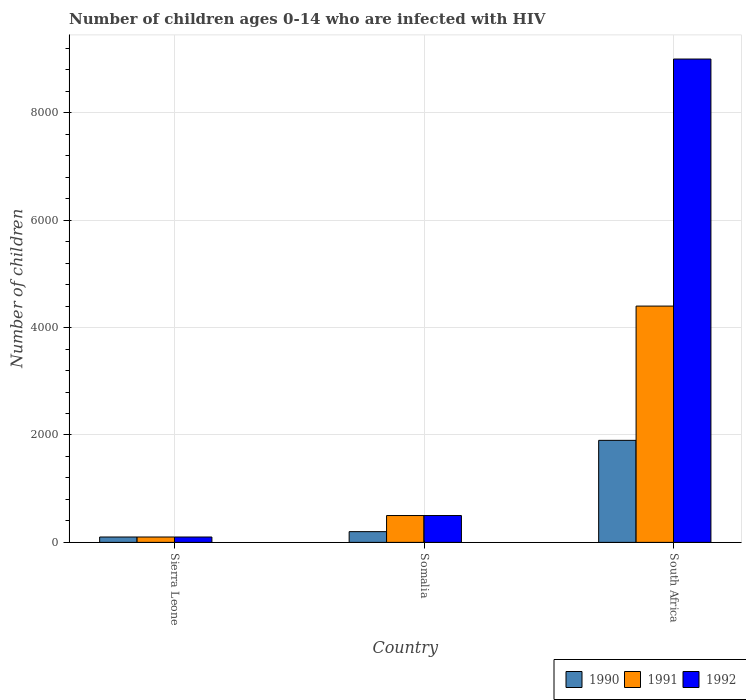How many different coloured bars are there?
Give a very brief answer. 3. How many groups of bars are there?
Offer a terse response. 3. Are the number of bars per tick equal to the number of legend labels?
Offer a very short reply. Yes. Are the number of bars on each tick of the X-axis equal?
Ensure brevity in your answer.  Yes. How many bars are there on the 2nd tick from the right?
Your answer should be very brief. 3. What is the label of the 2nd group of bars from the left?
Provide a short and direct response. Somalia. What is the number of HIV infected children in 1991 in Sierra Leone?
Give a very brief answer. 100. Across all countries, what is the maximum number of HIV infected children in 1992?
Give a very brief answer. 9000. Across all countries, what is the minimum number of HIV infected children in 1991?
Your answer should be very brief. 100. In which country was the number of HIV infected children in 1990 maximum?
Give a very brief answer. South Africa. In which country was the number of HIV infected children in 1990 minimum?
Your response must be concise. Sierra Leone. What is the total number of HIV infected children in 1991 in the graph?
Provide a short and direct response. 5000. What is the difference between the number of HIV infected children in 1992 in Somalia and that in South Africa?
Ensure brevity in your answer.  -8500. What is the difference between the number of HIV infected children in 1991 in Somalia and the number of HIV infected children in 1990 in South Africa?
Offer a very short reply. -1400. What is the average number of HIV infected children in 1991 per country?
Make the answer very short. 1666.67. What is the difference between the number of HIV infected children of/in 1990 and number of HIV infected children of/in 1992 in Somalia?
Your answer should be very brief. -300. What is the ratio of the number of HIV infected children in 1991 in Somalia to that in South Africa?
Your answer should be very brief. 0.11. What is the difference between the highest and the second highest number of HIV infected children in 1990?
Make the answer very short. 100. What is the difference between the highest and the lowest number of HIV infected children in 1990?
Offer a terse response. 1800. Is the sum of the number of HIV infected children in 1991 in Sierra Leone and South Africa greater than the maximum number of HIV infected children in 1992 across all countries?
Provide a short and direct response. No. What does the 1st bar from the right in Sierra Leone represents?
Offer a very short reply. 1992. Is it the case that in every country, the sum of the number of HIV infected children in 1990 and number of HIV infected children in 1991 is greater than the number of HIV infected children in 1992?
Provide a succinct answer. No. How many bars are there?
Offer a terse response. 9. Are the values on the major ticks of Y-axis written in scientific E-notation?
Your response must be concise. No. Does the graph contain any zero values?
Ensure brevity in your answer.  No. Where does the legend appear in the graph?
Your answer should be very brief. Bottom right. What is the title of the graph?
Your response must be concise. Number of children ages 0-14 who are infected with HIV. What is the label or title of the Y-axis?
Your response must be concise. Number of children. What is the Number of children in 1990 in Sierra Leone?
Make the answer very short. 100. What is the Number of children in 1991 in Sierra Leone?
Your response must be concise. 100. What is the Number of children in 1992 in Sierra Leone?
Keep it short and to the point. 100. What is the Number of children in 1990 in Somalia?
Provide a short and direct response. 200. What is the Number of children of 1991 in Somalia?
Your response must be concise. 500. What is the Number of children in 1992 in Somalia?
Keep it short and to the point. 500. What is the Number of children in 1990 in South Africa?
Your response must be concise. 1900. What is the Number of children in 1991 in South Africa?
Your answer should be very brief. 4400. What is the Number of children in 1992 in South Africa?
Your answer should be very brief. 9000. Across all countries, what is the maximum Number of children in 1990?
Keep it short and to the point. 1900. Across all countries, what is the maximum Number of children in 1991?
Ensure brevity in your answer.  4400. Across all countries, what is the maximum Number of children of 1992?
Keep it short and to the point. 9000. Across all countries, what is the minimum Number of children of 1990?
Provide a succinct answer. 100. Across all countries, what is the minimum Number of children of 1991?
Provide a short and direct response. 100. Across all countries, what is the minimum Number of children of 1992?
Offer a very short reply. 100. What is the total Number of children of 1990 in the graph?
Your answer should be compact. 2200. What is the total Number of children of 1992 in the graph?
Offer a terse response. 9600. What is the difference between the Number of children of 1990 in Sierra Leone and that in Somalia?
Keep it short and to the point. -100. What is the difference between the Number of children of 1991 in Sierra Leone and that in Somalia?
Ensure brevity in your answer.  -400. What is the difference between the Number of children of 1992 in Sierra Leone and that in Somalia?
Offer a terse response. -400. What is the difference between the Number of children of 1990 in Sierra Leone and that in South Africa?
Ensure brevity in your answer.  -1800. What is the difference between the Number of children of 1991 in Sierra Leone and that in South Africa?
Offer a terse response. -4300. What is the difference between the Number of children of 1992 in Sierra Leone and that in South Africa?
Your response must be concise. -8900. What is the difference between the Number of children in 1990 in Somalia and that in South Africa?
Your response must be concise. -1700. What is the difference between the Number of children of 1991 in Somalia and that in South Africa?
Provide a succinct answer. -3900. What is the difference between the Number of children of 1992 in Somalia and that in South Africa?
Ensure brevity in your answer.  -8500. What is the difference between the Number of children of 1990 in Sierra Leone and the Number of children of 1991 in Somalia?
Keep it short and to the point. -400. What is the difference between the Number of children in 1990 in Sierra Leone and the Number of children in 1992 in Somalia?
Your answer should be very brief. -400. What is the difference between the Number of children in 1991 in Sierra Leone and the Number of children in 1992 in Somalia?
Provide a succinct answer. -400. What is the difference between the Number of children in 1990 in Sierra Leone and the Number of children in 1991 in South Africa?
Keep it short and to the point. -4300. What is the difference between the Number of children of 1990 in Sierra Leone and the Number of children of 1992 in South Africa?
Ensure brevity in your answer.  -8900. What is the difference between the Number of children of 1991 in Sierra Leone and the Number of children of 1992 in South Africa?
Your answer should be very brief. -8900. What is the difference between the Number of children of 1990 in Somalia and the Number of children of 1991 in South Africa?
Give a very brief answer. -4200. What is the difference between the Number of children of 1990 in Somalia and the Number of children of 1992 in South Africa?
Make the answer very short. -8800. What is the difference between the Number of children in 1991 in Somalia and the Number of children in 1992 in South Africa?
Your answer should be very brief. -8500. What is the average Number of children of 1990 per country?
Provide a short and direct response. 733.33. What is the average Number of children of 1991 per country?
Provide a short and direct response. 1666.67. What is the average Number of children in 1992 per country?
Offer a very short reply. 3200. What is the difference between the Number of children of 1990 and Number of children of 1991 in Sierra Leone?
Keep it short and to the point. 0. What is the difference between the Number of children of 1991 and Number of children of 1992 in Sierra Leone?
Provide a succinct answer. 0. What is the difference between the Number of children of 1990 and Number of children of 1991 in Somalia?
Offer a very short reply. -300. What is the difference between the Number of children in 1990 and Number of children in 1992 in Somalia?
Provide a succinct answer. -300. What is the difference between the Number of children in 1991 and Number of children in 1992 in Somalia?
Offer a very short reply. 0. What is the difference between the Number of children in 1990 and Number of children in 1991 in South Africa?
Provide a short and direct response. -2500. What is the difference between the Number of children of 1990 and Number of children of 1992 in South Africa?
Your answer should be very brief. -7100. What is the difference between the Number of children in 1991 and Number of children in 1992 in South Africa?
Provide a succinct answer. -4600. What is the ratio of the Number of children of 1990 in Sierra Leone to that in Somalia?
Your response must be concise. 0.5. What is the ratio of the Number of children in 1992 in Sierra Leone to that in Somalia?
Keep it short and to the point. 0.2. What is the ratio of the Number of children in 1990 in Sierra Leone to that in South Africa?
Keep it short and to the point. 0.05. What is the ratio of the Number of children of 1991 in Sierra Leone to that in South Africa?
Provide a succinct answer. 0.02. What is the ratio of the Number of children of 1992 in Sierra Leone to that in South Africa?
Your answer should be compact. 0.01. What is the ratio of the Number of children of 1990 in Somalia to that in South Africa?
Your response must be concise. 0.11. What is the ratio of the Number of children in 1991 in Somalia to that in South Africa?
Provide a succinct answer. 0.11. What is the ratio of the Number of children of 1992 in Somalia to that in South Africa?
Provide a short and direct response. 0.06. What is the difference between the highest and the second highest Number of children of 1990?
Provide a short and direct response. 1700. What is the difference between the highest and the second highest Number of children of 1991?
Your answer should be compact. 3900. What is the difference between the highest and the second highest Number of children of 1992?
Provide a short and direct response. 8500. What is the difference between the highest and the lowest Number of children of 1990?
Give a very brief answer. 1800. What is the difference between the highest and the lowest Number of children in 1991?
Provide a succinct answer. 4300. What is the difference between the highest and the lowest Number of children in 1992?
Make the answer very short. 8900. 